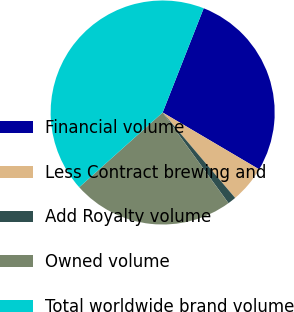Convert chart to OTSL. <chart><loc_0><loc_0><loc_500><loc_500><pie_chart><fcel>Financial volume<fcel>Less Contract brewing and<fcel>Add Royalty volume<fcel>Owned volume<fcel>Total worldwide brand volume<nl><fcel>27.51%<fcel>5.33%<fcel>1.2%<fcel>23.37%<fcel>42.6%<nl></chart> 